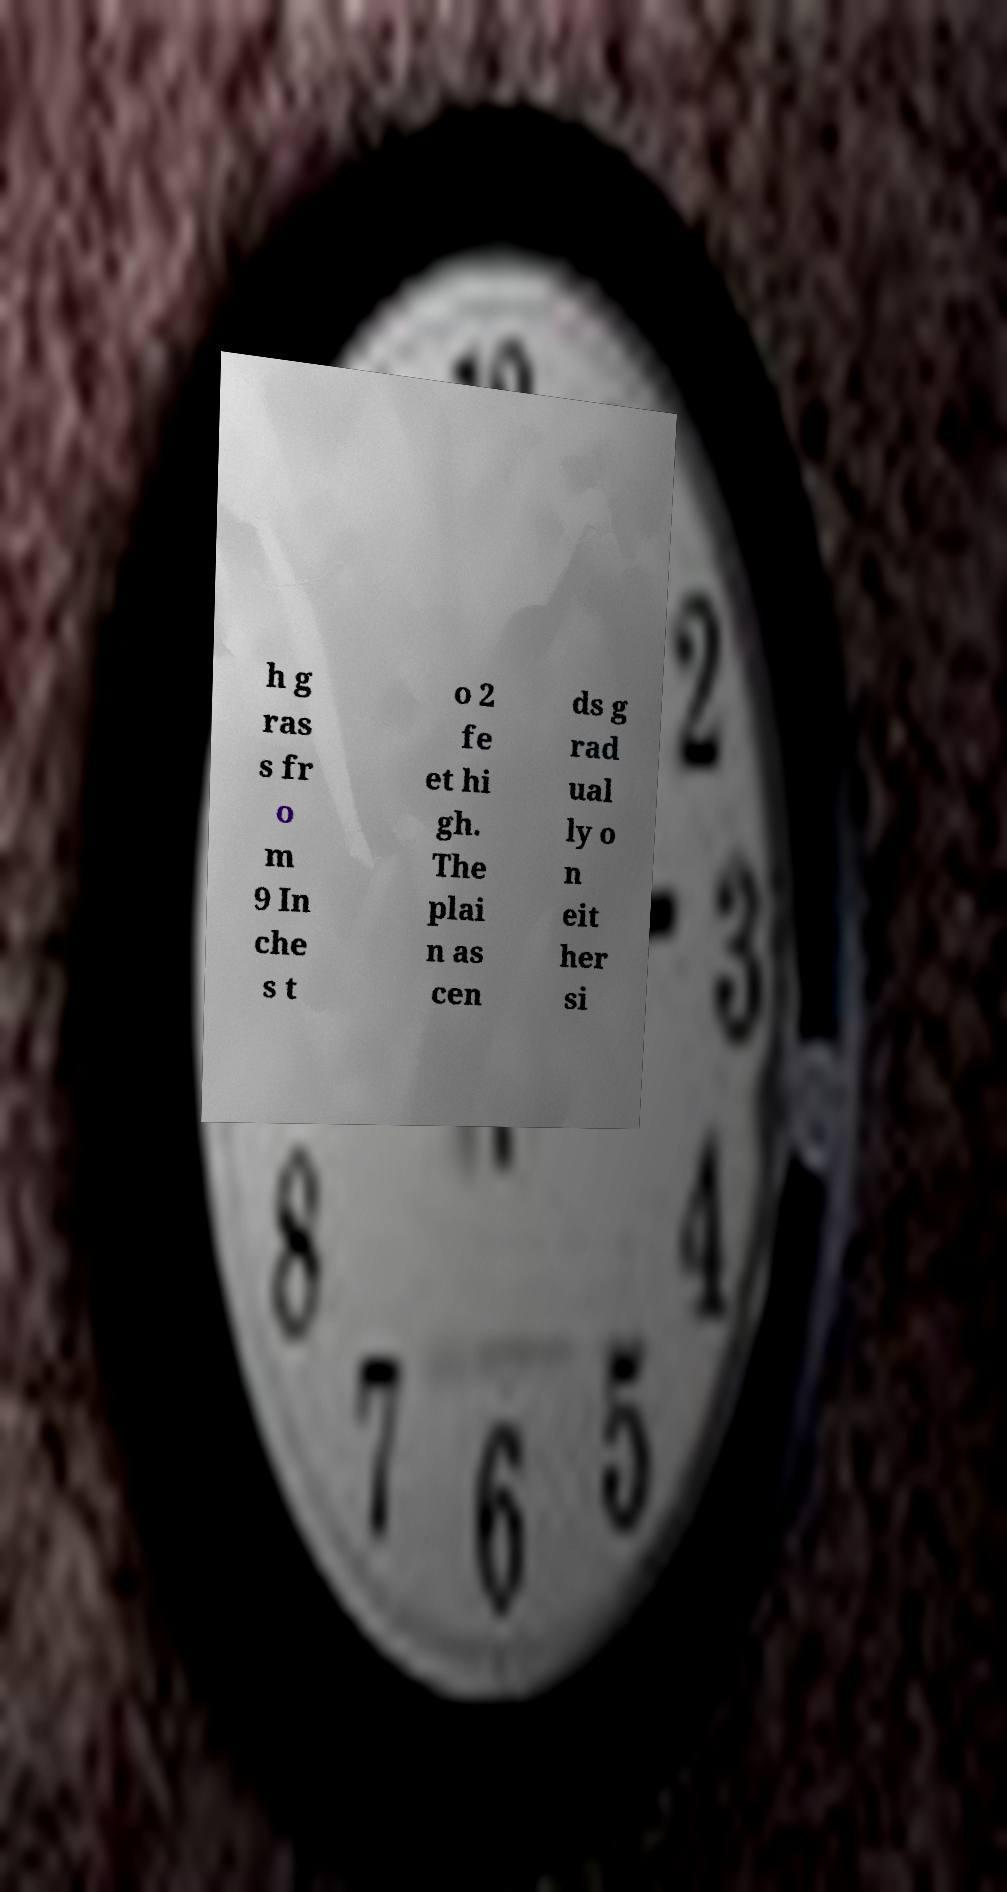I need the written content from this picture converted into text. Can you do that? h g ras s fr o m 9 In che s t o 2 fe et hi gh. The plai n as cen ds g rad ual ly o n eit her si 